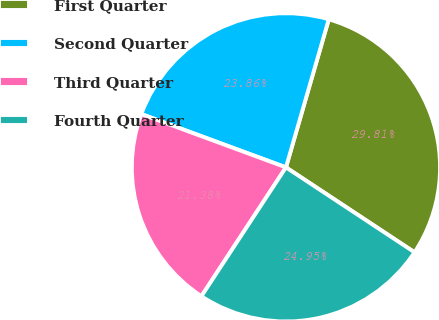<chart> <loc_0><loc_0><loc_500><loc_500><pie_chart><fcel>First Quarter<fcel>Second Quarter<fcel>Third Quarter<fcel>Fourth Quarter<nl><fcel>29.81%<fcel>23.86%<fcel>21.38%<fcel>24.95%<nl></chart> 